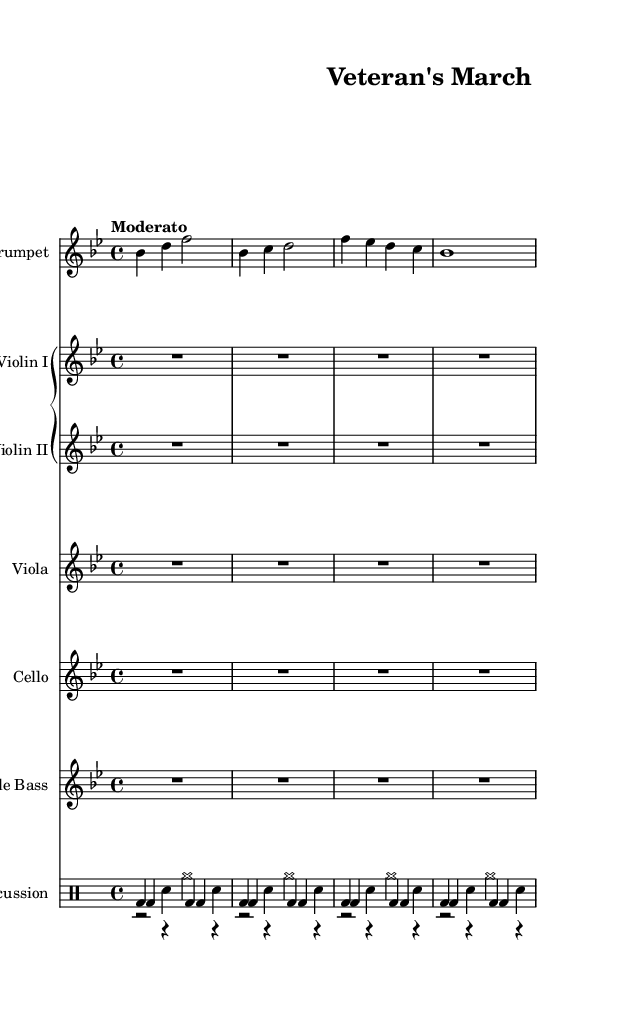What is the key signature of this music? The key signature is B flat major, which has two flats: B flat and E flat. This can be identified by looking at the key signature at the beginning of the staff where the two flats are placed.
Answer: B flat major What is the time signature of this music? The time signature is 4/4, which is indicated at the beginning of the score. The top number (4) indicates there are four beats per measure, and the bottom number (4) tells us that a quarter note gets one beat.
Answer: 4/4 What is the tempo marking for the piece? The tempo marking is "Moderato," which is typically a moderate speed. This is found directly above the staff and provides guidance on how quickly the piece should be played.
Answer: Moderato How many instruments are used in this score? The score features a total of six types of instruments: trumpet, two violins, viola, cello, double bass, and percussion instruments. Counting each distinct instrumental section gives us the total.
Answer: Six What type of marching rhythm is used in the snare part? The snare part uses a march-like rhythm, indicated by the repeated pattern of bass drum and snare hits, typical in military or patriotic marches. This rhythmic pattern contributes to the overall march feel of the piece.
Answer: March-like What instruments are included in the Grand Staff? The Grand Staff includes Violin I, Violin II, Viola, Cello, and Double Bass. All these instruments are shown under the Grand Staff heading, which suggests they are played together in a unified manner.
Answer: Violin I, Violin II, Viola, Cello, Double Bass What role does the trumpet play in this piece? The trumpet acts as a melodic leader in the orchestration, as indicated by its presence at the top of the score and the unique melodic line it provides distinct from the strings and percussion.
Answer: Melodic leader 